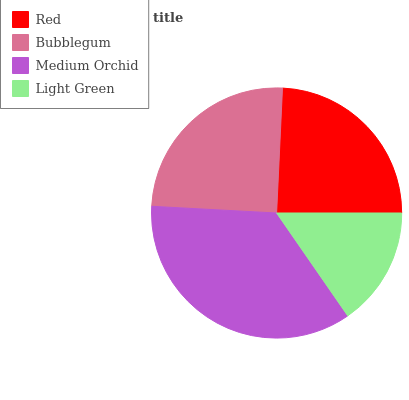Is Light Green the minimum?
Answer yes or no. Yes. Is Medium Orchid the maximum?
Answer yes or no. Yes. Is Bubblegum the minimum?
Answer yes or no. No. Is Bubblegum the maximum?
Answer yes or no. No. Is Bubblegum greater than Red?
Answer yes or no. Yes. Is Red less than Bubblegum?
Answer yes or no. Yes. Is Red greater than Bubblegum?
Answer yes or no. No. Is Bubblegum less than Red?
Answer yes or no. No. Is Bubblegum the high median?
Answer yes or no. Yes. Is Red the low median?
Answer yes or no. Yes. Is Red the high median?
Answer yes or no. No. Is Light Green the low median?
Answer yes or no. No. 